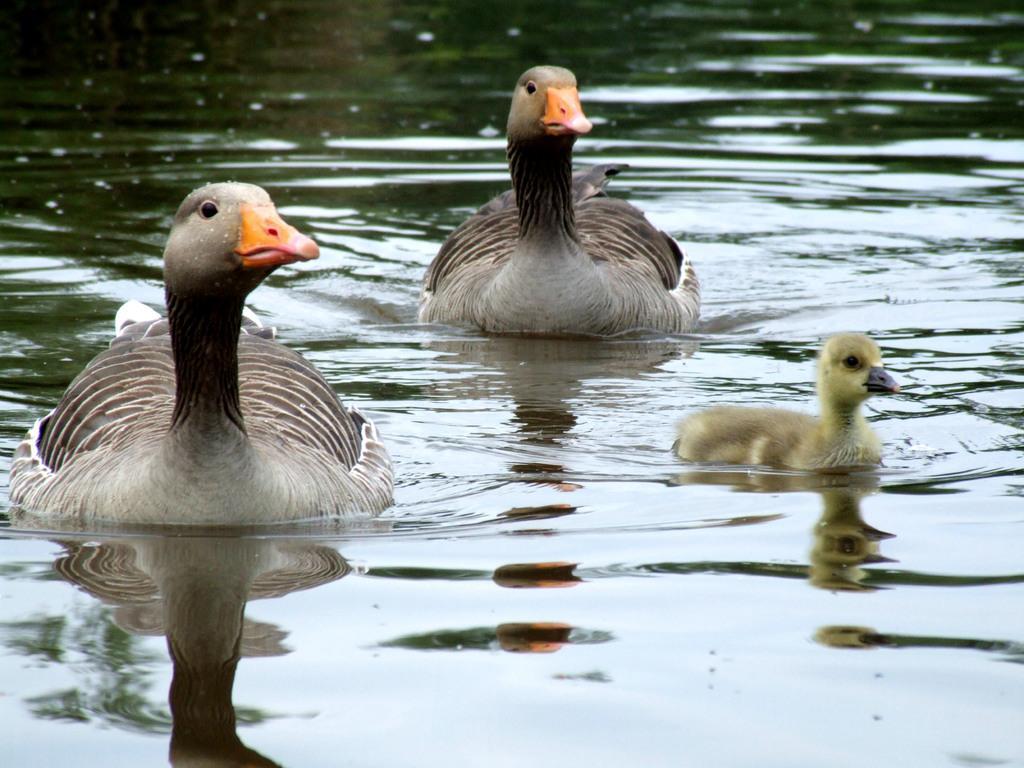How would you summarize this image in a sentence or two? This image consists of ducks in the water. At the bottom, there is water. 